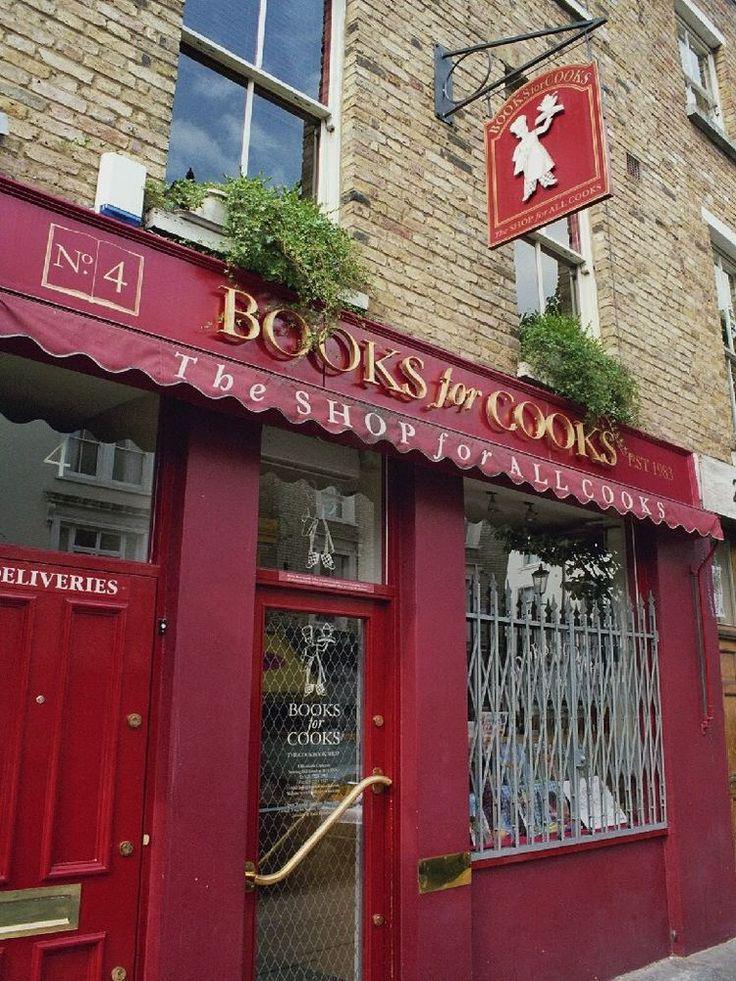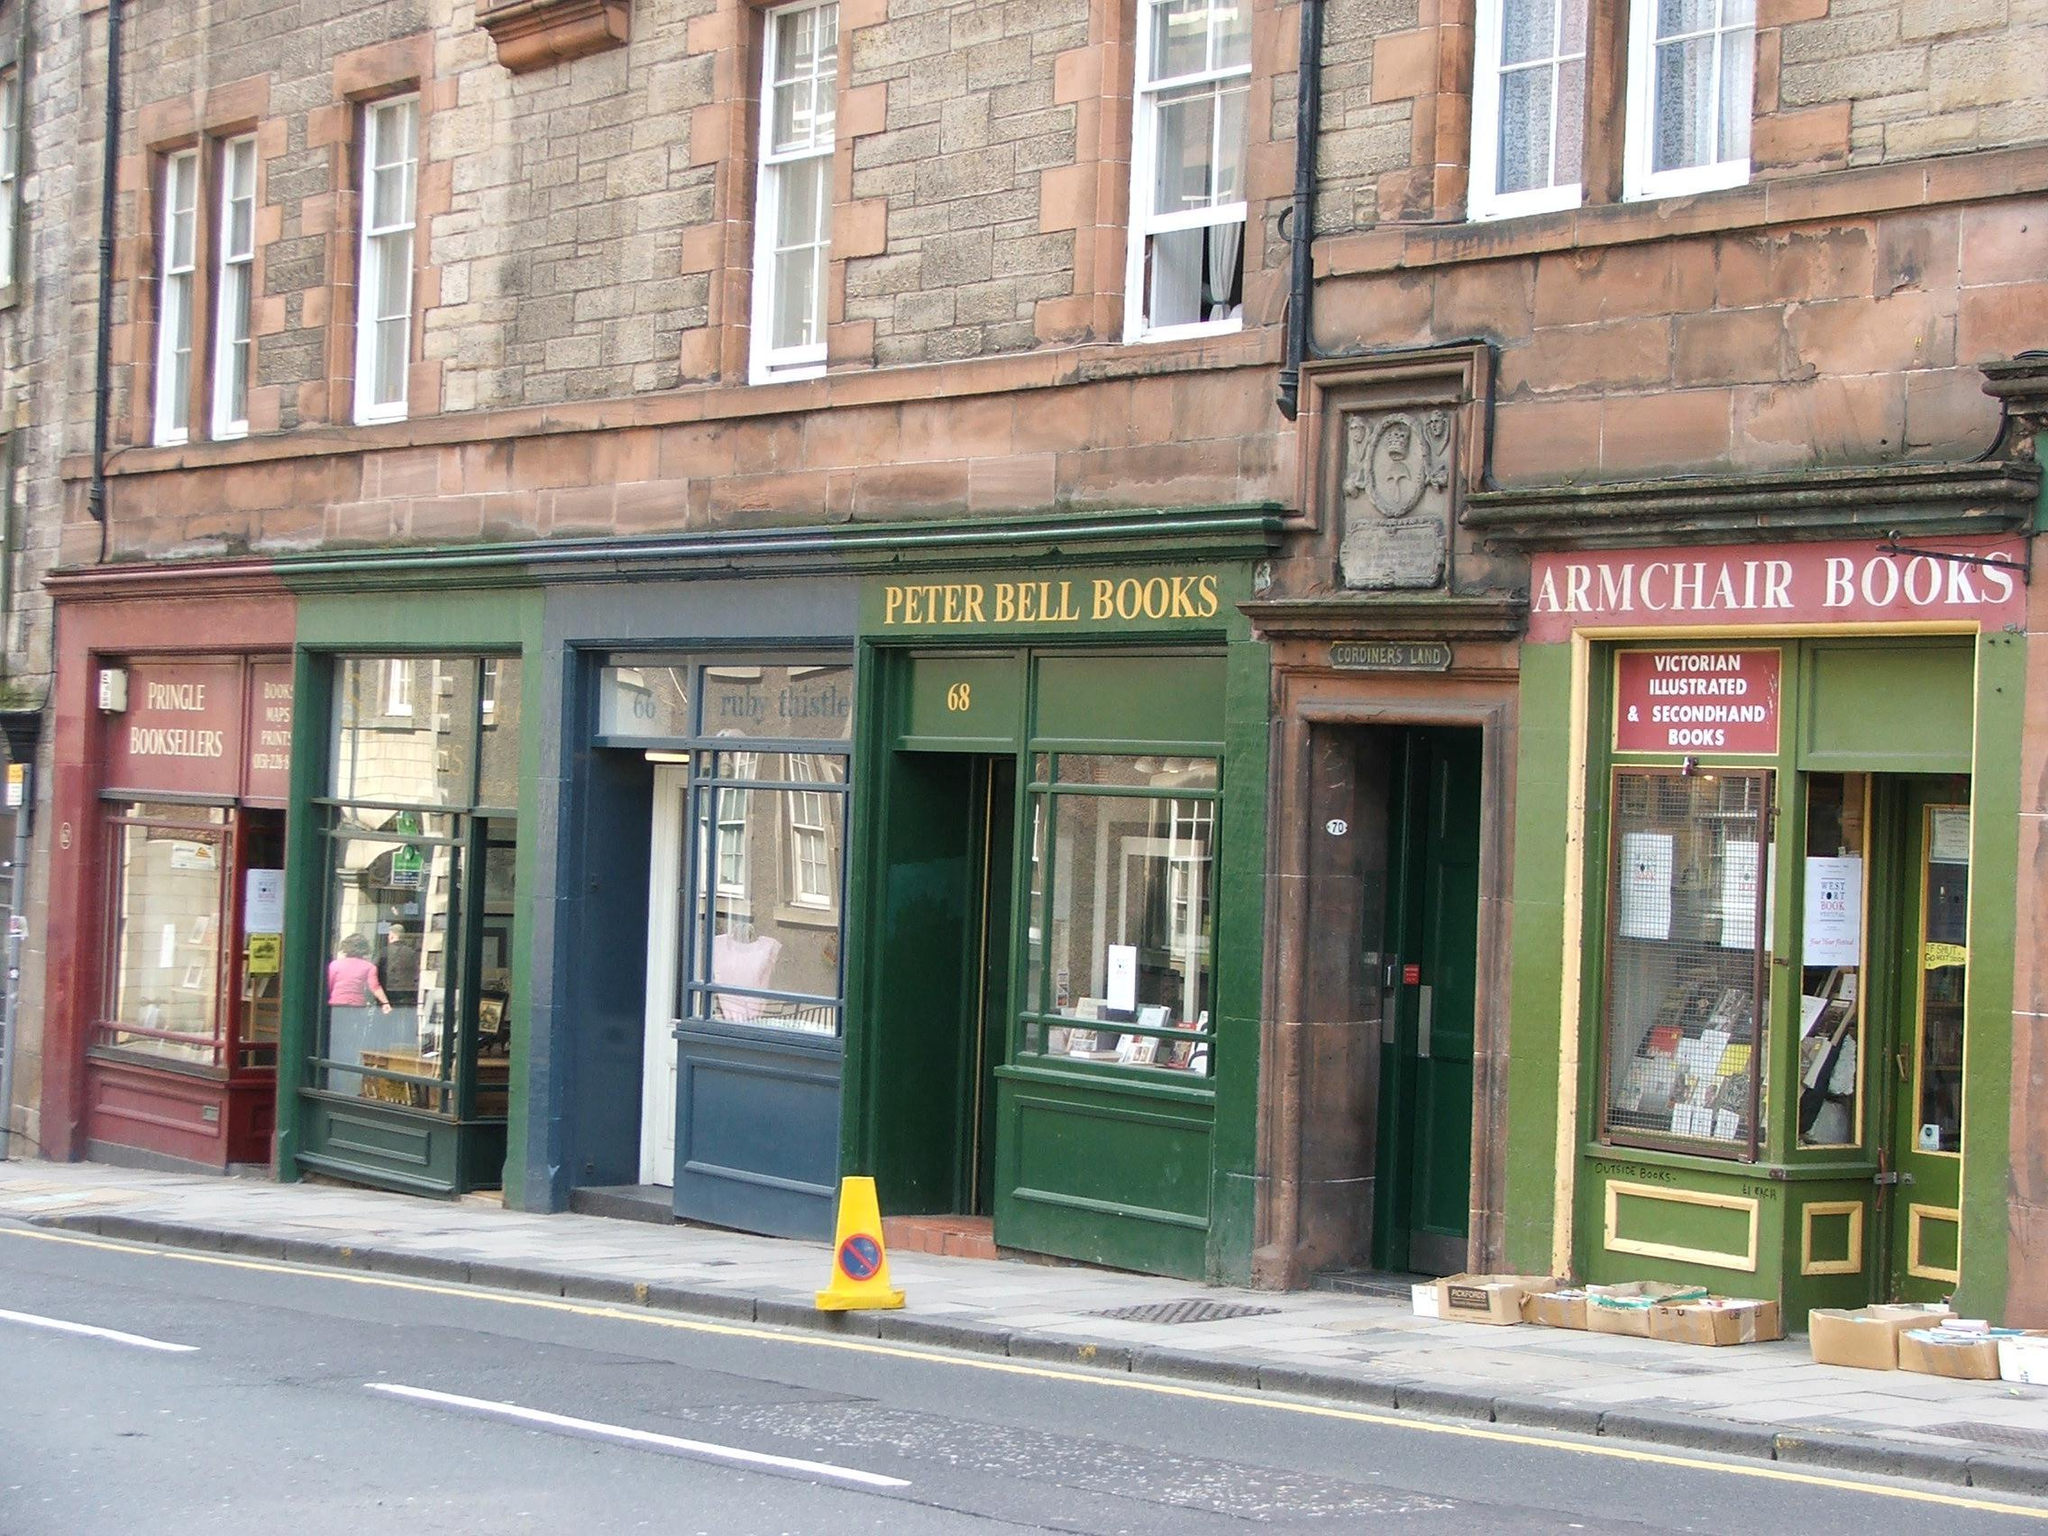The first image is the image on the left, the second image is the image on the right. Given the left and right images, does the statement "The left image depicts a painted red bookshop exterior with some type of awning over its front door and display window." hold true? Answer yes or no. Yes. The first image is the image on the left, the second image is the image on the right. Evaluate the accuracy of this statement regarding the images: "there is a bookstore in a brick building with green painted trim on the door and window". Is it true? Answer yes or no. Yes. 